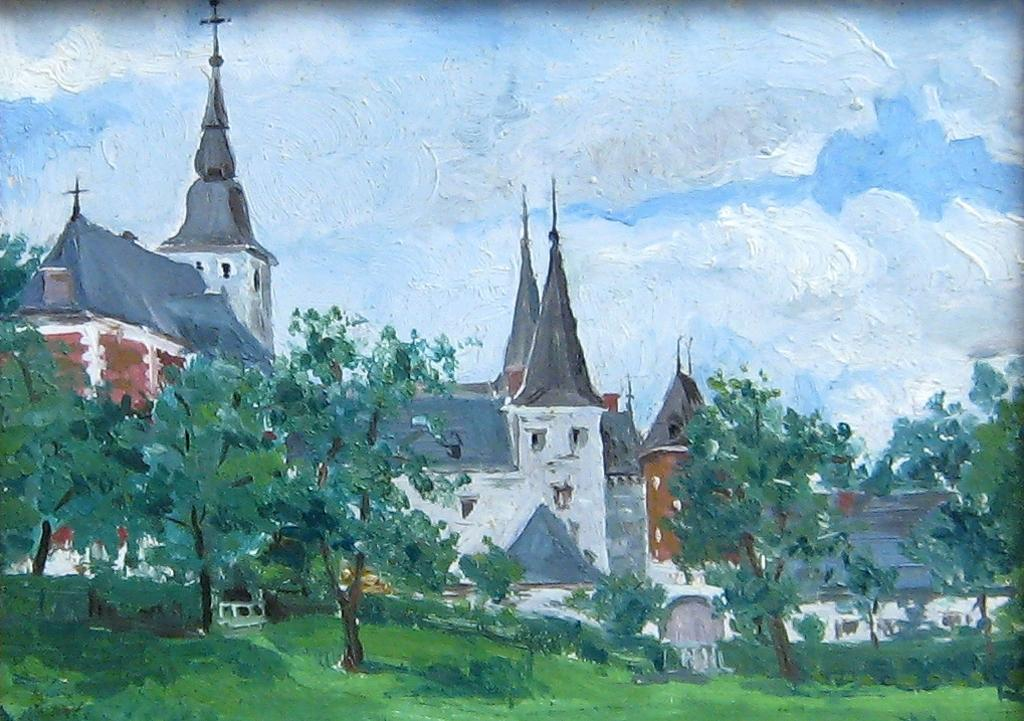What type of artwork is depicted in the image? The image is a painting. What can be seen in the middle of the painting? There are houses, trees, grass, and the sky visible in the middle of the painting. What is the condition of the sky in the painting? The sky is visible in the middle of the painting, and there are clouds in the sky. Where is the bag hanging in the painting? There is no bag present in the painting. What type of yam is growing in the middle of the painting? There is no yam present in the painting; it features houses, trees, grass, and the sky. 